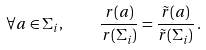Convert formula to latex. <formula><loc_0><loc_0><loc_500><loc_500>\forall a \in \Sigma _ { i } , \quad \frac { r ( a ) } { r ( \Sigma _ { i } ) } = \frac { \tilde { r } ( a ) } { \tilde { r } ( \Sigma _ { i } ) } \, .</formula> 